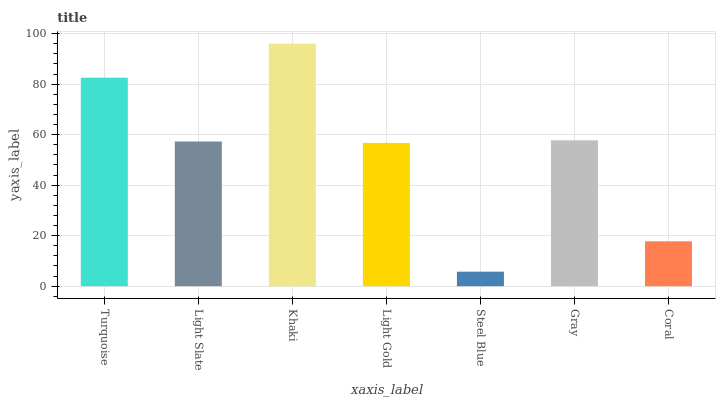Is Steel Blue the minimum?
Answer yes or no. Yes. Is Khaki the maximum?
Answer yes or no. Yes. Is Light Slate the minimum?
Answer yes or no. No. Is Light Slate the maximum?
Answer yes or no. No. Is Turquoise greater than Light Slate?
Answer yes or no. Yes. Is Light Slate less than Turquoise?
Answer yes or no. Yes. Is Light Slate greater than Turquoise?
Answer yes or no. No. Is Turquoise less than Light Slate?
Answer yes or no. No. Is Light Slate the high median?
Answer yes or no. Yes. Is Light Slate the low median?
Answer yes or no. Yes. Is Steel Blue the high median?
Answer yes or no. No. Is Turquoise the low median?
Answer yes or no. No. 